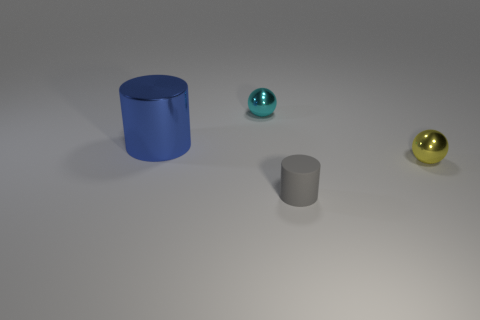Subtract all gray cylinders. How many cylinders are left? 1 Add 2 cyan objects. How many objects exist? 6 Add 3 red shiny objects. How many red shiny objects exist? 3 Subtract 0 green cylinders. How many objects are left? 4 Subtract all yellow balls. Subtract all green cylinders. How many balls are left? 1 Subtract all cyan blocks. How many gray spheres are left? 0 Subtract all cyan metallic balls. Subtract all small cyan metallic cubes. How many objects are left? 3 Add 1 small cylinders. How many small cylinders are left? 2 